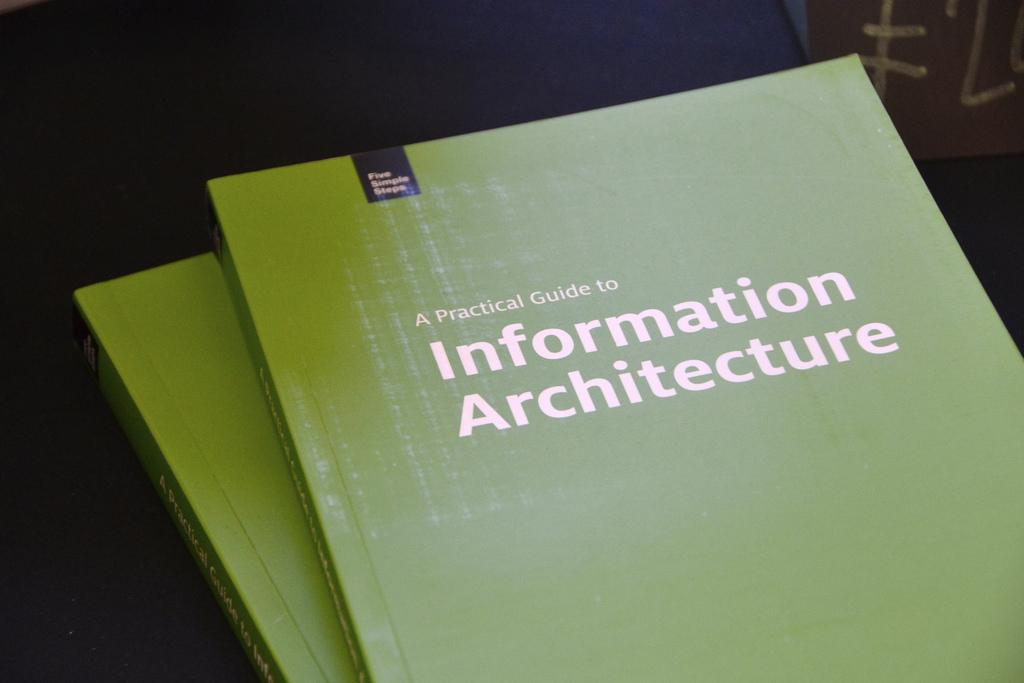Provide a one-sentence caption for the provided image. a green book that says a Practical guide to information. 